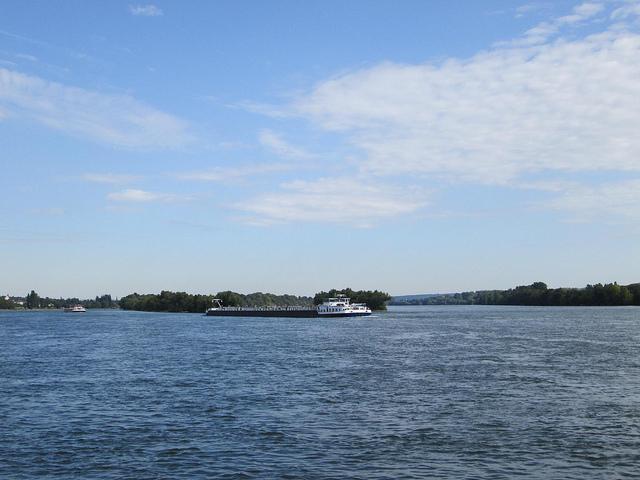What color is the water?
Quick response, please. Blue. Is this a high speed train?
Be succinct. No. Is the water choppy?
Short answer required. No. What kind of boat is this?
Be succinct. Ferry. Are there building at the back?
Concise answer only. No. Can you see mountains in the picture?
Answer briefly. No. What is green in this photo?
Keep it brief. Trees. What time of day is it?
Give a very brief answer. Noon. What sky is blue?
Quick response, please. Above water. 